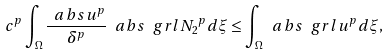Convert formula to latex. <formula><loc_0><loc_0><loc_500><loc_500>c ^ { p } \int _ { \Omega } \frac { \ a b s { u } ^ { p } } { \delta ^ { p } } \ a b s { \ g r l N _ { 2 } } ^ { p } d \xi \leq \int _ { \Omega } \ a b s { \ g r l u } ^ { p } d \xi ,</formula> 